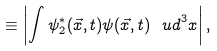<formula> <loc_0><loc_0><loc_500><loc_500>\equiv \left | \int \psi _ { 2 } ^ { * } ( \vec { x } , t ) \psi ( \vec { x } , t ) \, { \ u d } ^ { 3 } { x } \right | ,</formula> 